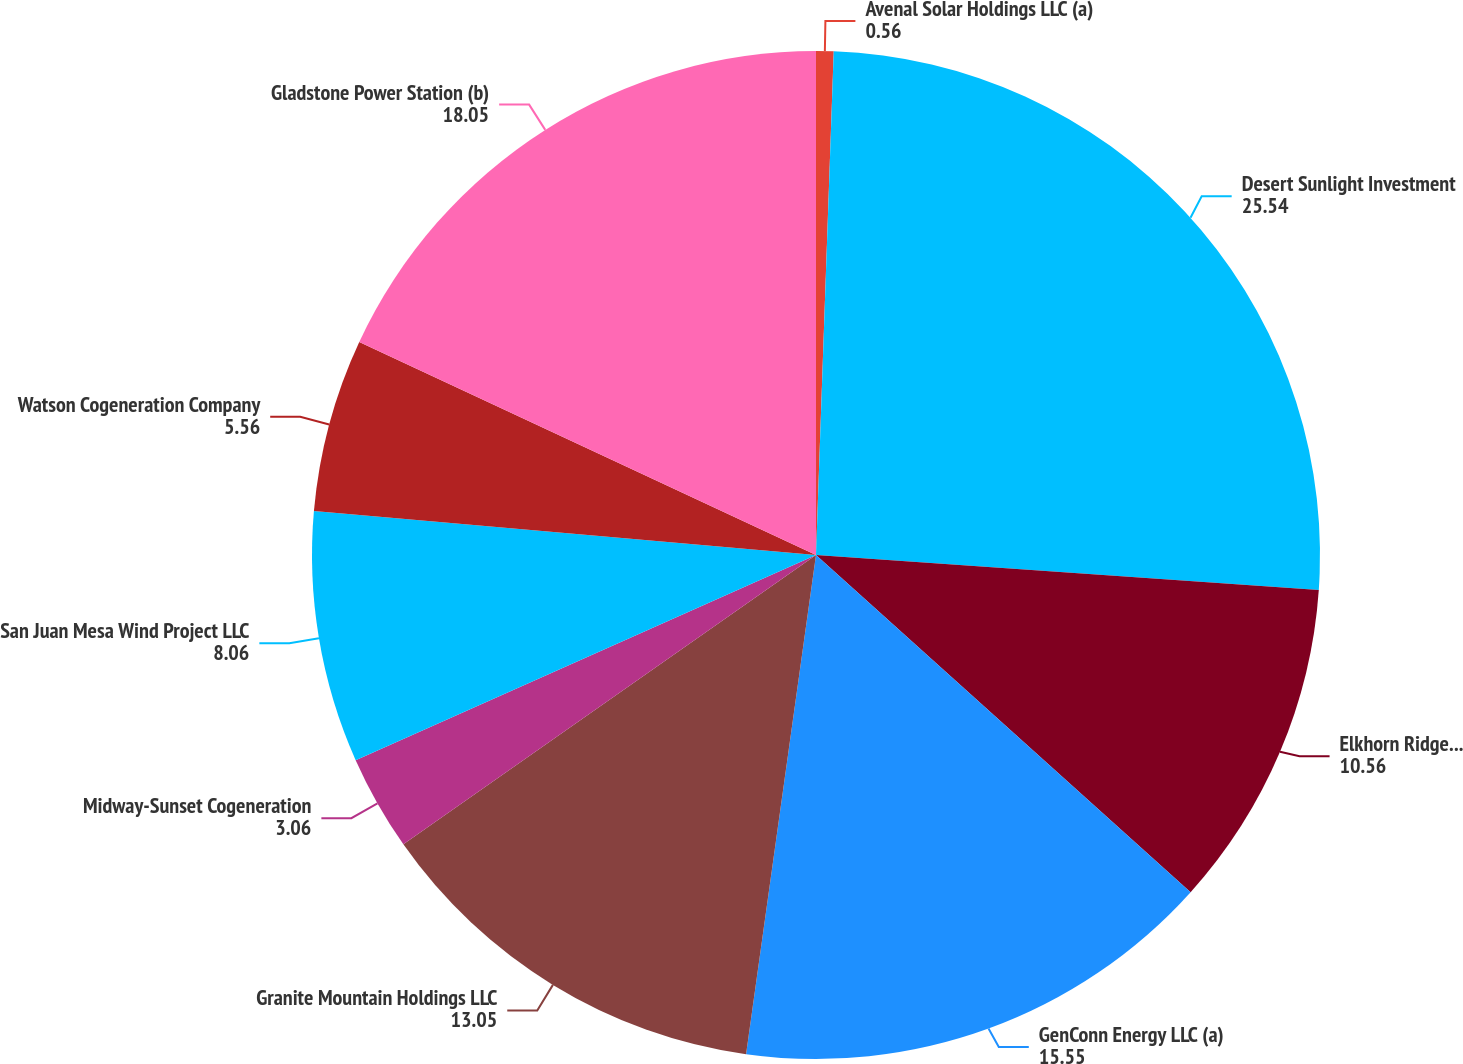<chart> <loc_0><loc_0><loc_500><loc_500><pie_chart><fcel>Avenal Solar Holdings LLC (a)<fcel>Desert Sunlight Investment<fcel>Elkhorn Ridge Wind LLC (a)<fcel>GenConn Energy LLC (a)<fcel>Granite Mountain Holdings LLC<fcel>Midway-Sunset Cogeneration<fcel>San Juan Mesa Wind Project LLC<fcel>Watson Cogeneration Company<fcel>Gladstone Power Station (b)<nl><fcel>0.56%<fcel>25.54%<fcel>10.56%<fcel>15.55%<fcel>13.05%<fcel>3.06%<fcel>8.06%<fcel>5.56%<fcel>18.05%<nl></chart> 